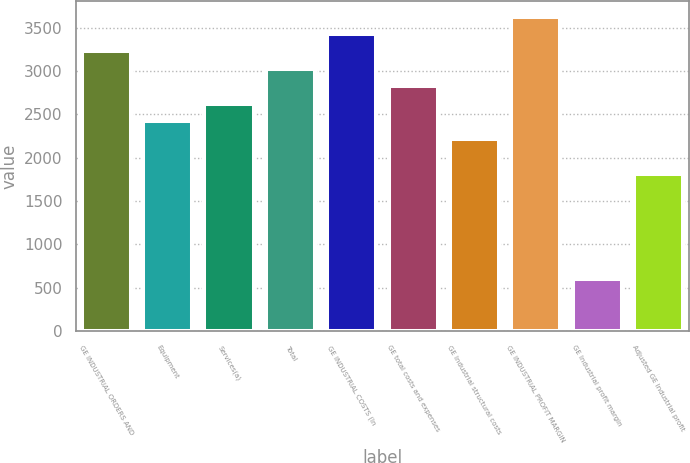Convert chart to OTSL. <chart><loc_0><loc_0><loc_500><loc_500><bar_chart><fcel>GE INDUSTRIAL ORDERS AND<fcel>Equipment<fcel>Services(a)<fcel>Total<fcel>GE INDUSTRIAL COSTS (In<fcel>GE total costs and expenses<fcel>GE Industrial structural costs<fcel>GE INDUSTRIAL PROFIT MARGIN<fcel>GE Industrial profit margin<fcel>Adjusted GE Industrial profit<nl><fcel>3226.59<fcel>2420.19<fcel>2621.79<fcel>3024.99<fcel>3428.19<fcel>2823.39<fcel>2218.59<fcel>3629.79<fcel>605.79<fcel>1815.39<nl></chart> 